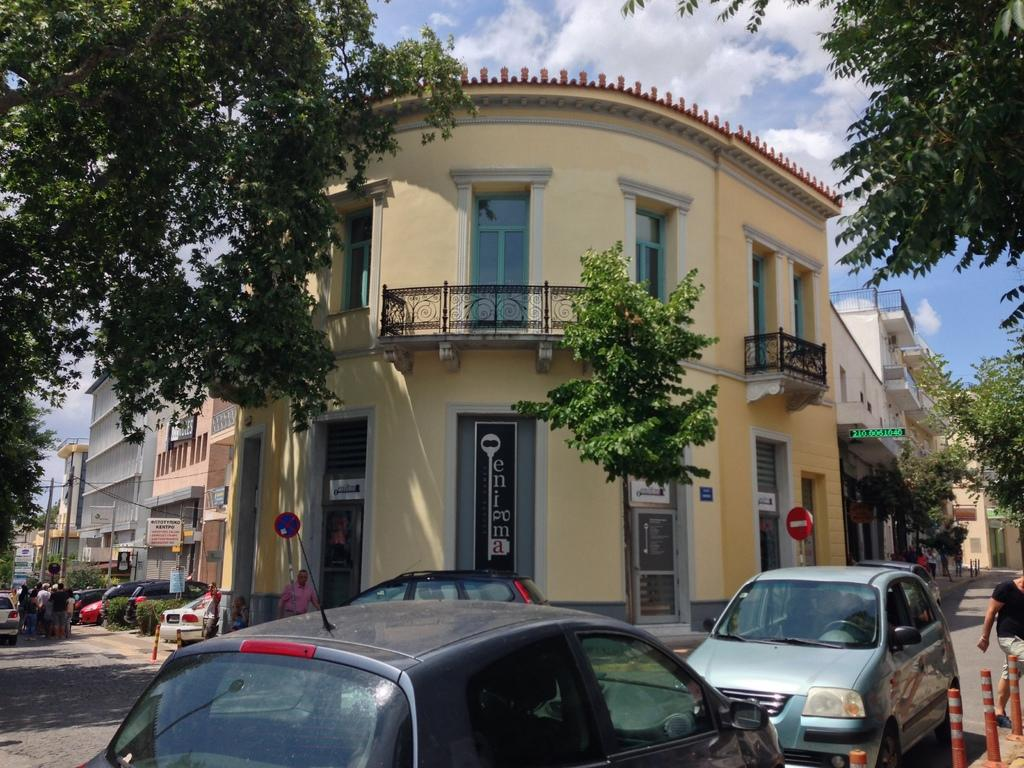What type of structures can be seen in the image? There are buildings in the image. What is happening on the road in front of the buildings? Vehicles are present on the road, and there are persons on the road as well. What else can be seen in the image besides the buildings and road? There are poles visible in the image. What is visible in the background of the image? Trees and the sky are visible in the background of the image. Can you tell me how many eggs are being used in the magic trick performed by the duck in the image? There is no duck or magic trick present in the image, and therefore no such activity can be observed. 